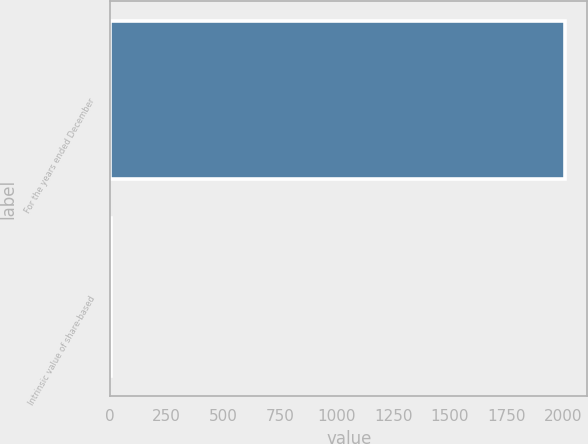Convert chart to OTSL. <chart><loc_0><loc_0><loc_500><loc_500><bar_chart><fcel>For the years ended December<fcel>Intrinsic value of share-based<nl><fcel>2006<fcel>4.7<nl></chart> 